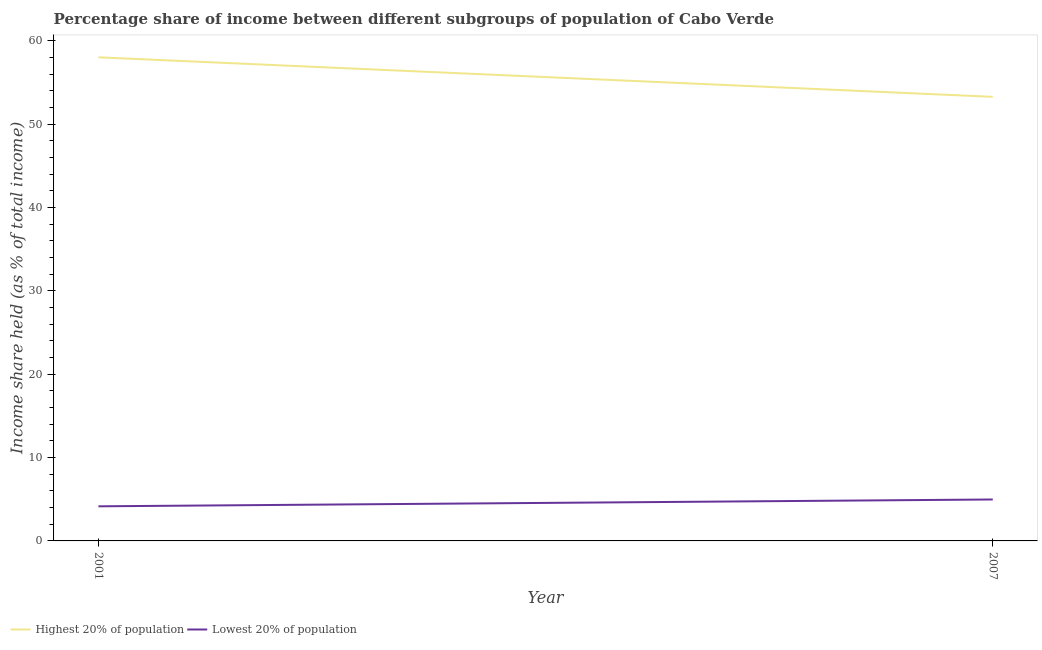Does the line corresponding to income share held by lowest 20% of the population intersect with the line corresponding to income share held by highest 20% of the population?
Provide a succinct answer. No. What is the income share held by highest 20% of the population in 2007?
Your answer should be very brief. 53.27. Across all years, what is the maximum income share held by lowest 20% of the population?
Keep it short and to the point. 4.97. Across all years, what is the minimum income share held by highest 20% of the population?
Make the answer very short. 53.27. In which year was the income share held by highest 20% of the population maximum?
Make the answer very short. 2001. In which year was the income share held by lowest 20% of the population minimum?
Keep it short and to the point. 2001. What is the total income share held by lowest 20% of the population in the graph?
Offer a terse response. 9.12. What is the difference between the income share held by lowest 20% of the population in 2001 and that in 2007?
Ensure brevity in your answer.  -0.82. What is the difference between the income share held by lowest 20% of the population in 2001 and the income share held by highest 20% of the population in 2007?
Provide a succinct answer. -49.12. What is the average income share held by lowest 20% of the population per year?
Make the answer very short. 4.56. In the year 2007, what is the difference between the income share held by lowest 20% of the population and income share held by highest 20% of the population?
Your answer should be very brief. -48.3. What is the ratio of the income share held by highest 20% of the population in 2001 to that in 2007?
Offer a terse response. 1.09. In how many years, is the income share held by lowest 20% of the population greater than the average income share held by lowest 20% of the population taken over all years?
Offer a very short reply. 1. Does the income share held by lowest 20% of the population monotonically increase over the years?
Your answer should be very brief. Yes. Is the income share held by lowest 20% of the population strictly less than the income share held by highest 20% of the population over the years?
Your answer should be compact. Yes. How many lines are there?
Your answer should be very brief. 2. What is the difference between two consecutive major ticks on the Y-axis?
Your answer should be compact. 10. Are the values on the major ticks of Y-axis written in scientific E-notation?
Offer a very short reply. No. Does the graph contain any zero values?
Offer a very short reply. No. Where does the legend appear in the graph?
Your answer should be compact. Bottom left. What is the title of the graph?
Keep it short and to the point. Percentage share of income between different subgroups of population of Cabo Verde. Does "Secondary education" appear as one of the legend labels in the graph?
Your answer should be very brief. No. What is the label or title of the Y-axis?
Ensure brevity in your answer.  Income share held (as % of total income). What is the Income share held (as % of total income) of Highest 20% of population in 2001?
Offer a very short reply. 58.01. What is the Income share held (as % of total income) in Lowest 20% of population in 2001?
Provide a succinct answer. 4.15. What is the Income share held (as % of total income) of Highest 20% of population in 2007?
Your answer should be compact. 53.27. What is the Income share held (as % of total income) in Lowest 20% of population in 2007?
Provide a succinct answer. 4.97. Across all years, what is the maximum Income share held (as % of total income) in Highest 20% of population?
Your answer should be very brief. 58.01. Across all years, what is the maximum Income share held (as % of total income) of Lowest 20% of population?
Your response must be concise. 4.97. Across all years, what is the minimum Income share held (as % of total income) in Highest 20% of population?
Offer a very short reply. 53.27. Across all years, what is the minimum Income share held (as % of total income) of Lowest 20% of population?
Your response must be concise. 4.15. What is the total Income share held (as % of total income) in Highest 20% of population in the graph?
Give a very brief answer. 111.28. What is the total Income share held (as % of total income) of Lowest 20% of population in the graph?
Make the answer very short. 9.12. What is the difference between the Income share held (as % of total income) in Highest 20% of population in 2001 and that in 2007?
Give a very brief answer. 4.74. What is the difference between the Income share held (as % of total income) of Lowest 20% of population in 2001 and that in 2007?
Your response must be concise. -0.82. What is the difference between the Income share held (as % of total income) of Highest 20% of population in 2001 and the Income share held (as % of total income) of Lowest 20% of population in 2007?
Offer a very short reply. 53.04. What is the average Income share held (as % of total income) of Highest 20% of population per year?
Provide a succinct answer. 55.64. What is the average Income share held (as % of total income) in Lowest 20% of population per year?
Your response must be concise. 4.56. In the year 2001, what is the difference between the Income share held (as % of total income) in Highest 20% of population and Income share held (as % of total income) in Lowest 20% of population?
Offer a very short reply. 53.86. In the year 2007, what is the difference between the Income share held (as % of total income) in Highest 20% of population and Income share held (as % of total income) in Lowest 20% of population?
Your answer should be very brief. 48.3. What is the ratio of the Income share held (as % of total income) of Highest 20% of population in 2001 to that in 2007?
Provide a short and direct response. 1.09. What is the ratio of the Income share held (as % of total income) of Lowest 20% of population in 2001 to that in 2007?
Give a very brief answer. 0.83. What is the difference between the highest and the second highest Income share held (as % of total income) of Highest 20% of population?
Ensure brevity in your answer.  4.74. What is the difference between the highest and the second highest Income share held (as % of total income) of Lowest 20% of population?
Keep it short and to the point. 0.82. What is the difference between the highest and the lowest Income share held (as % of total income) in Highest 20% of population?
Provide a short and direct response. 4.74. What is the difference between the highest and the lowest Income share held (as % of total income) of Lowest 20% of population?
Make the answer very short. 0.82. 